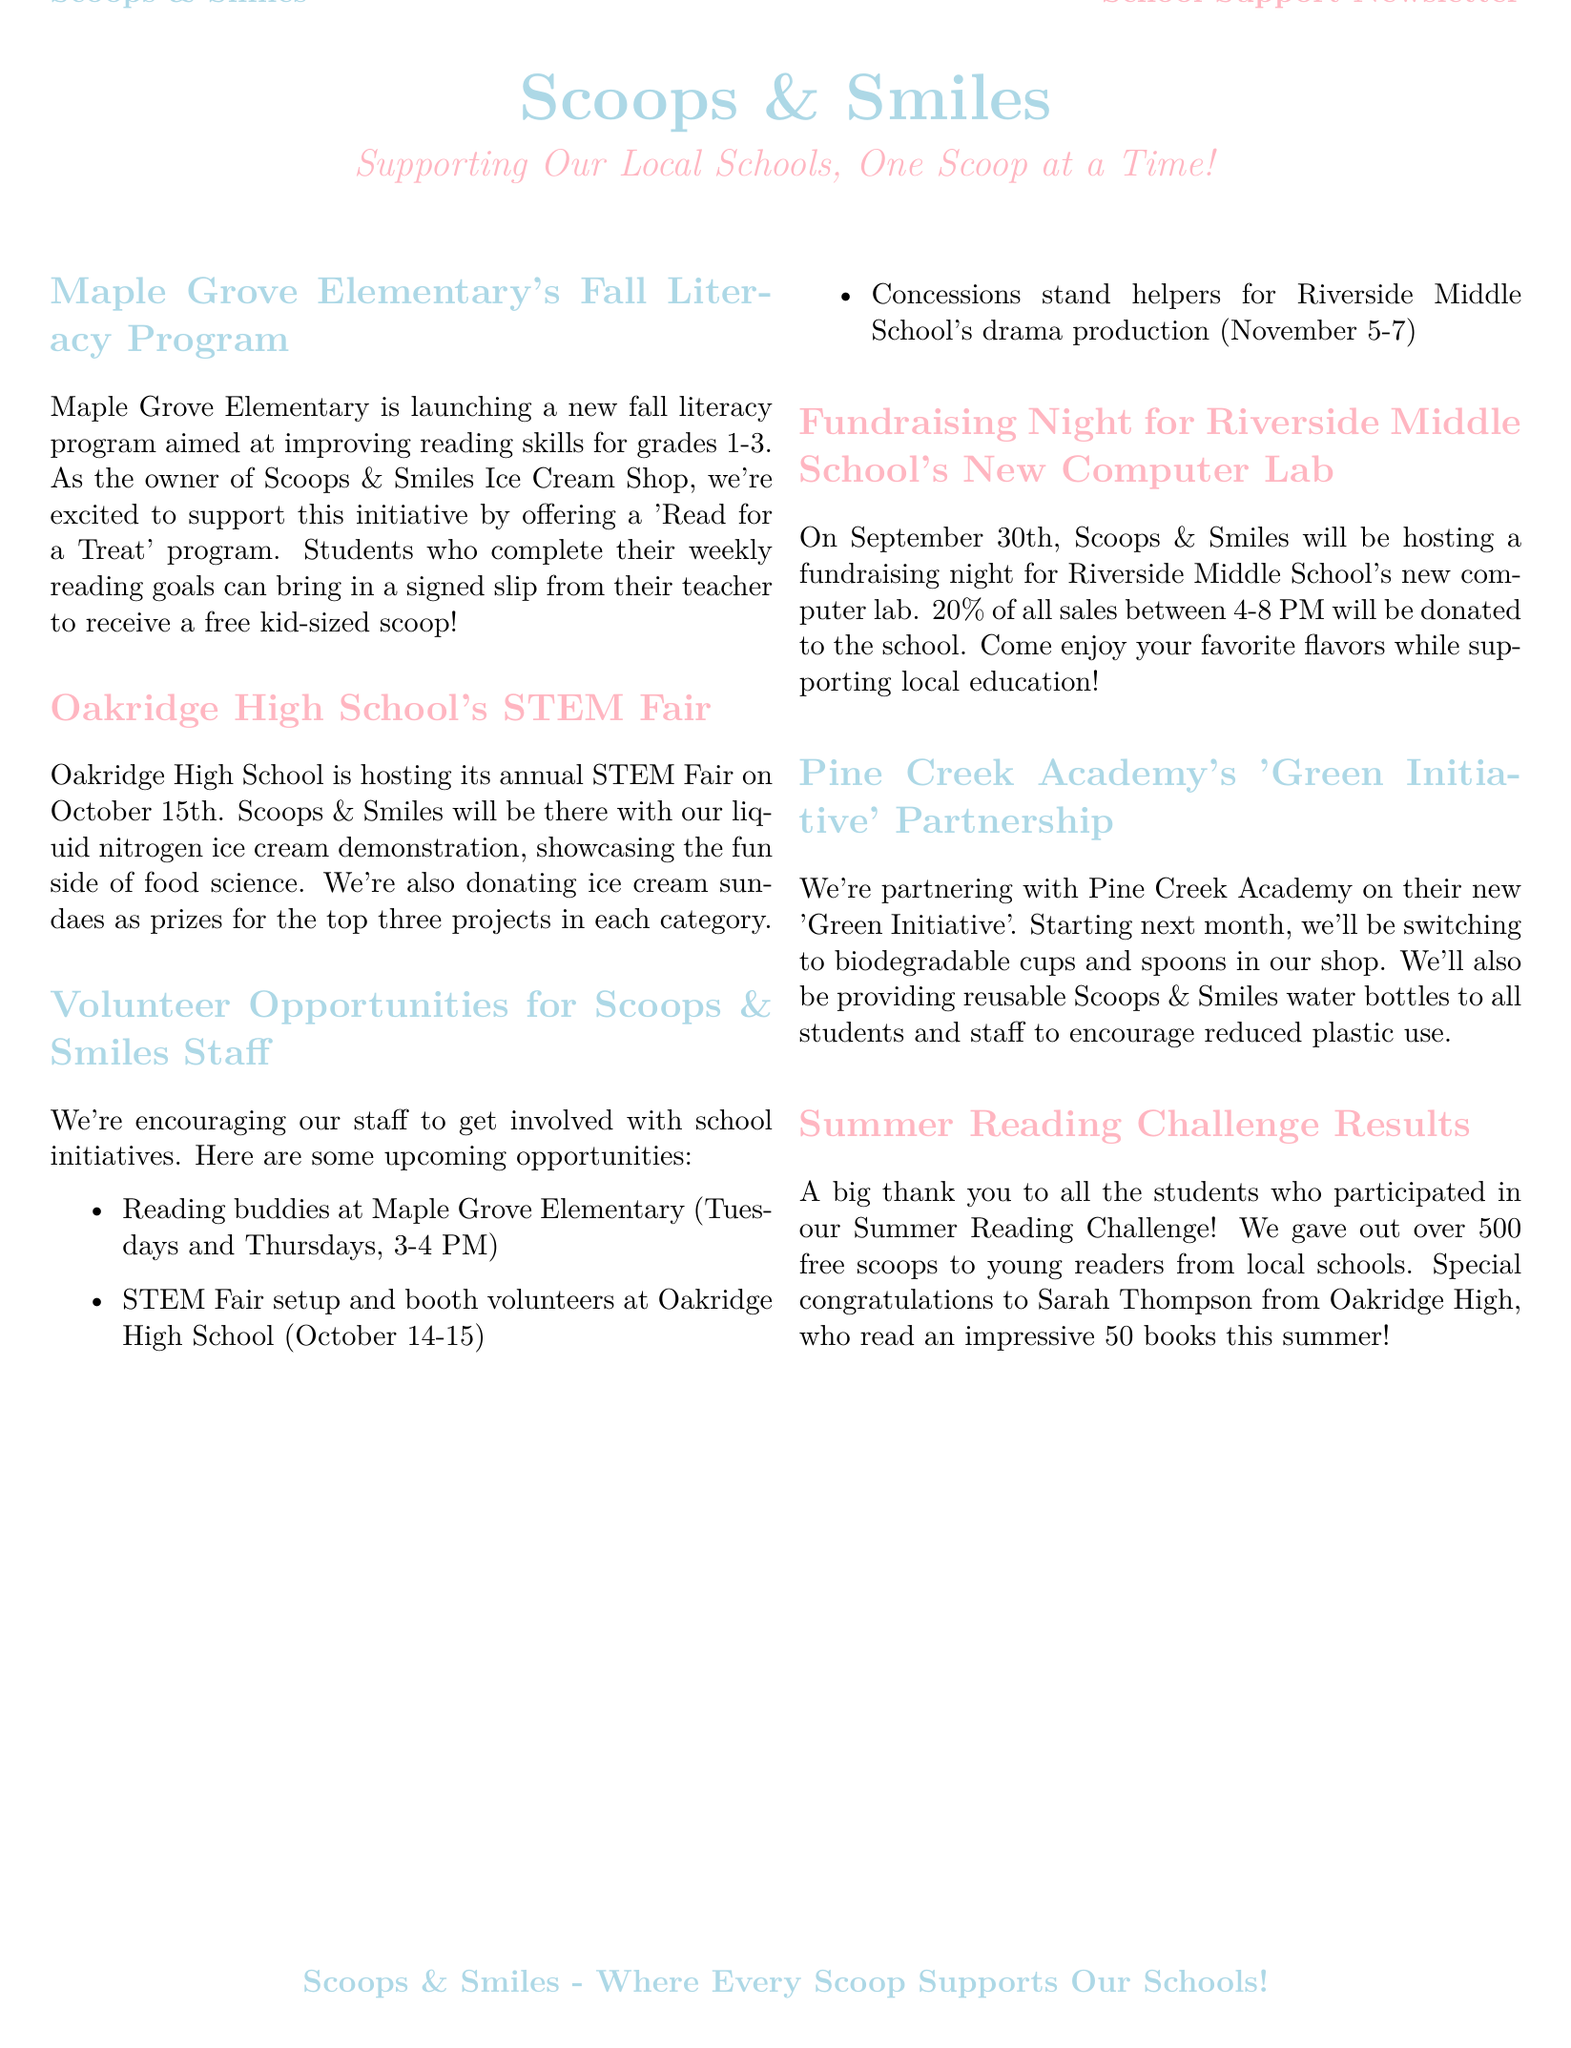What is the name of the literacy program? The name of the literacy program is mentioned as 'Fall Literacy Program' focused on grades 1-3 at Maple Grove Elementary.
Answer: Fall Literacy Program When is the STEM Fair taking place? The document specifies that the STEM Fair is on October 15th at Oakridge High School.
Answer: October 15th What percentage of sales will be donated during the fundraising night? The document states that 20% of all sales will be donated on the fundraising night for Riverside Middle School's new computer lab.
Answer: 20% What are staff encouraged to do? The newsletter encourages staff to get involved with school initiatives, highlighting their involvement in various activities.
Answer: Get involved What type of ice cream demonstration will Scoops & Smiles provide? The document mentions that Scoops & Smiles will showcase a liquid nitrogen ice cream demonstration at the STEM Fair.
Answer: Liquid nitrogen ice cream demonstration How many free scoops were given during the Summer Reading Challenge? The document states that over 500 free scoops were given to young readers participating in the Summer Reading Challenge.
Answer: Over 500 What initiative is Scoops & Smiles partnering with Pine Creek Academy on? The newsletter highlights a partnership with Pine Creek Academy on their new 'Green Initiative'.
Answer: Green Initiative When are reading buddies scheduled? The document provides the schedule for reading buddies at Maple Grove Elementary as Tuesdays and Thursdays, from 3-4 PM.
Answer: Tuesdays and Thursdays, 3-4 PM 